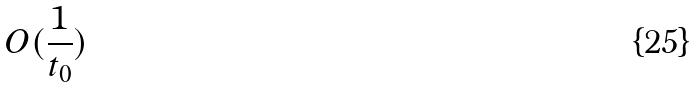Convert formula to latex. <formula><loc_0><loc_0><loc_500><loc_500>O ( \frac { 1 } { t _ { 0 } } )</formula> 